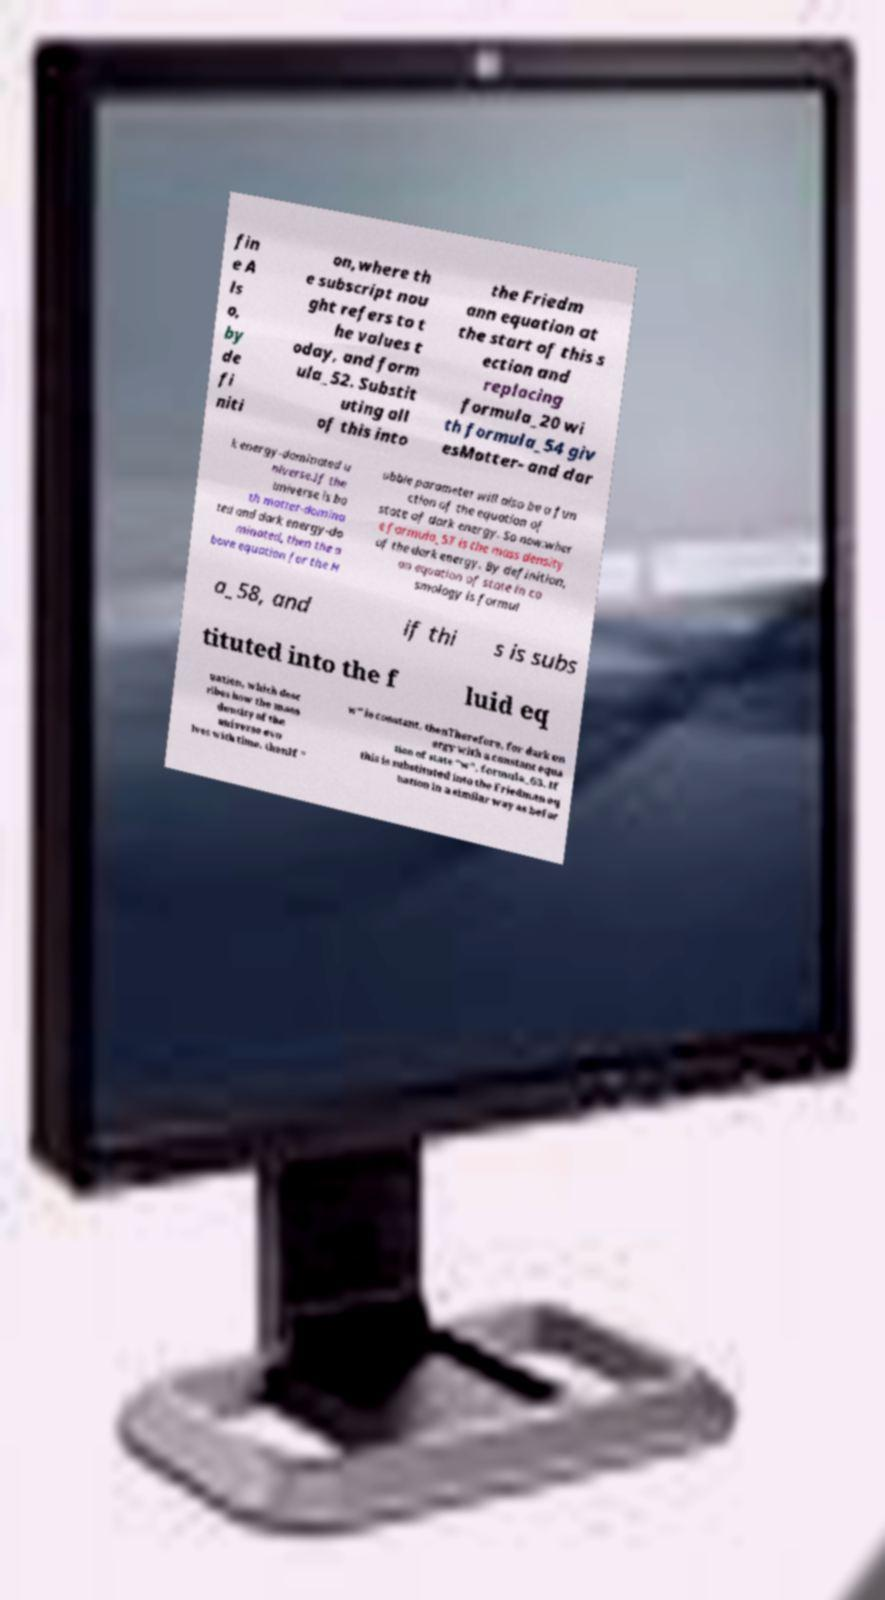Could you extract and type out the text from this image? fin e A ls o, by de fi niti on,where th e subscript nou ght refers to t he values t oday, and form ula_52. Substit uting all of this into the Friedm ann equation at the start of this s ection and replacing formula_20 wi th formula_54 giv esMatter- and dar k energy-dominated u niverse.If the universe is bo th matter-domina ted and dark energy-do minated, then the a bove equation for the H ubble parameter will also be a fun ction of the equation of state of dark energy. So now:wher e formula_57 is the mass density of the dark energy. By definition, an equation of state in co smology is formul a_58, and if thi s is subs tituted into the f luid eq uation, which desc ribes how the mass density of the universe evo lves with time, thenIf " w" is constant, thenTherefore, for dark en ergy with a constant equa tion of state "w", formula_63. If this is substituted into the Friedman eq uation in a similar way as befor 